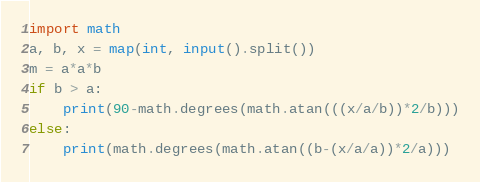<code> <loc_0><loc_0><loc_500><loc_500><_Python_>import math
a, b, x = map(int, input().split())
m = a*a*b
if b > a:
    print(90-math.degrees(math.atan(((x/a/b))*2/b)))
else:
    print(math.degrees(math.atan((b-(x/a/a))*2/a)))
</code> 